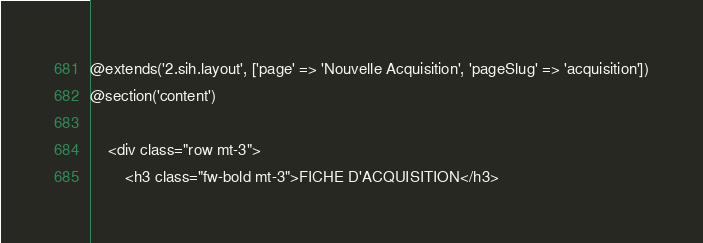Convert code to text. <code><loc_0><loc_0><loc_500><loc_500><_PHP_>@extends('2.sih.layout', ['page' => 'Nouvelle Acquisition', 'pageSlug' => 'acquisition'])
@section('content')

    <div class="row mt-3">
        <h3 class="fw-bold mt-3">FICHE D'ACQUISITION</h3></code> 